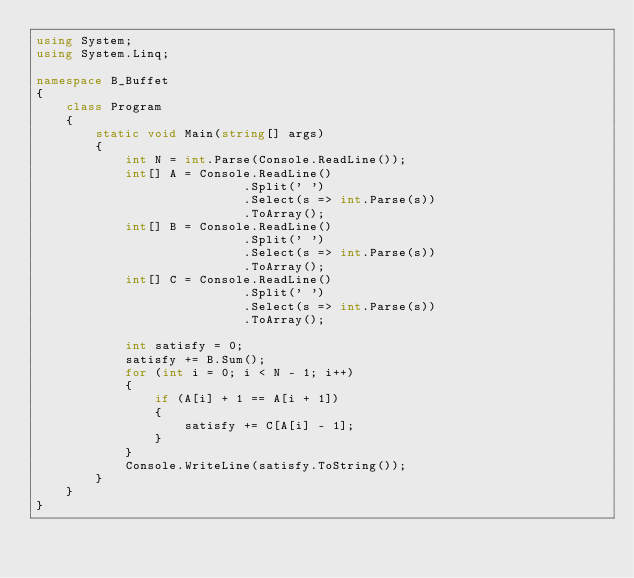<code> <loc_0><loc_0><loc_500><loc_500><_C#_>using System;
using System.Linq;

namespace B_Buffet
{
    class Program
    {
        static void Main(string[] args)
        {
            int N = int.Parse(Console.ReadLine());
            int[] A = Console.ReadLine()
                            .Split(' ')
                            .Select(s => int.Parse(s))
                            .ToArray();
            int[] B = Console.ReadLine()
                            .Split(' ')
                            .Select(s => int.Parse(s))
                            .ToArray();
            int[] C = Console.ReadLine()
                            .Split(' ')
                            .Select(s => int.Parse(s))
                            .ToArray();
            
            int satisfy = 0;
            satisfy += B.Sum();
            for (int i = 0; i < N - 1; i++)
            {
                if (A[i] + 1 == A[i + 1])
                {
                    satisfy += C[A[i] - 1];
                }
            }
            Console.WriteLine(satisfy.ToString());
        }
    }
}
</code> 